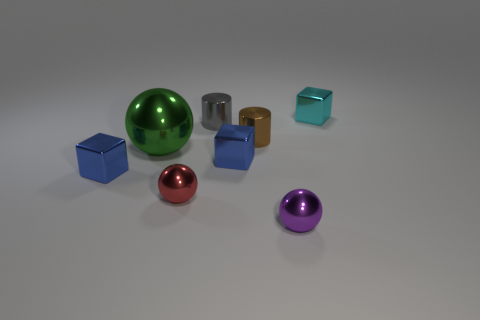There is a red metal thing that is the same size as the brown object; what is its shape?
Provide a succinct answer. Sphere. How many large balls have the same color as the large object?
Your answer should be very brief. 0. Does the small ball that is behind the purple object have the same material as the gray object?
Your answer should be very brief. Yes. What is the shape of the gray metal object?
Your answer should be compact. Cylinder. What number of green objects are either small metallic objects or large metal balls?
Offer a very short reply. 1. What number of other things are there of the same material as the large green ball
Provide a succinct answer. 7. There is a small blue thing that is left of the tiny gray thing; is it the same shape as the gray object?
Offer a very short reply. No. Are any gray rubber cylinders visible?
Your response must be concise. No. Is there any other thing that has the same shape as the tiny purple metallic thing?
Offer a very short reply. Yes. Are there more tiny metal cylinders that are in front of the tiny gray metal cylinder than brown cylinders?
Make the answer very short. No. 